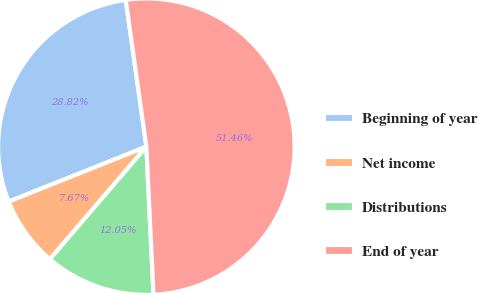<chart> <loc_0><loc_0><loc_500><loc_500><pie_chart><fcel>Beginning of year<fcel>Net income<fcel>Distributions<fcel>End of year<nl><fcel>28.82%<fcel>7.67%<fcel>12.05%<fcel>51.46%<nl></chart> 